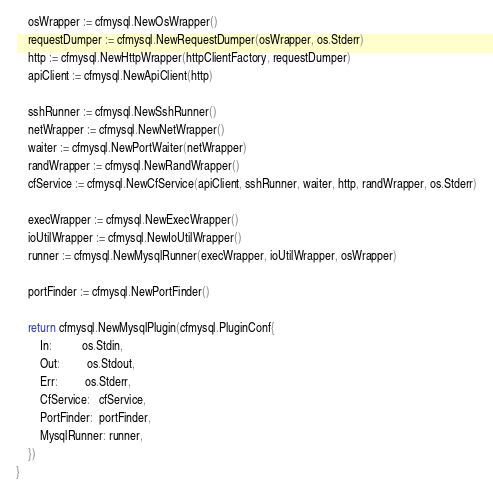<code> <loc_0><loc_0><loc_500><loc_500><_Go_>	osWrapper := cfmysql.NewOsWrapper()
	requestDumper := cfmysql.NewRequestDumper(osWrapper, os.Stderr)
	http := cfmysql.NewHttpWrapper(httpClientFactory, requestDumper)
	apiClient := cfmysql.NewApiClient(http)

	sshRunner := cfmysql.NewSshRunner()
	netWrapper := cfmysql.NewNetWrapper()
	waiter := cfmysql.NewPortWaiter(netWrapper)
	randWrapper := cfmysql.NewRandWrapper()
	cfService := cfmysql.NewCfService(apiClient, sshRunner, waiter, http, randWrapper, os.Stderr)

	execWrapper := cfmysql.NewExecWrapper()
	ioUtilWrapper := cfmysql.NewIoUtilWrapper()
	runner := cfmysql.NewMysqlRunner(execWrapper, ioUtilWrapper, osWrapper)

	portFinder := cfmysql.NewPortFinder()

	return cfmysql.NewMysqlPlugin(cfmysql.PluginConf{
		In:          os.Stdin,
		Out:         os.Stdout,
		Err:         os.Stderr,
		CfService:   cfService,
		PortFinder:  portFinder,
		MysqlRunner: runner,
	})
}
</code> 